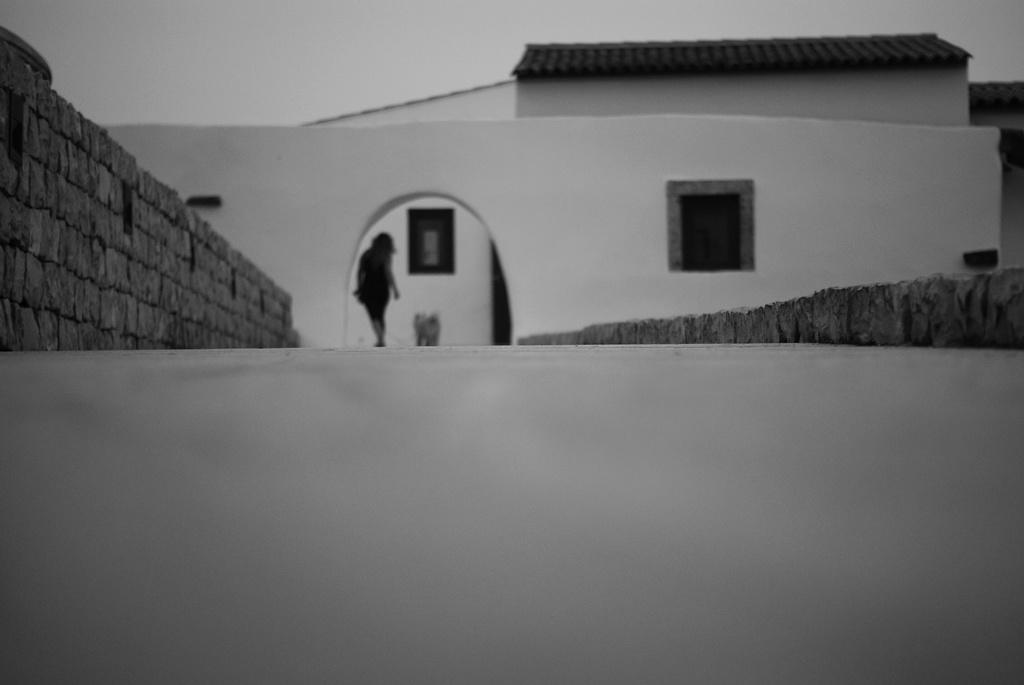What type of structure is visible in the image? There is a building in the image. What architectural feature can be seen on the building? There is a brick wall in the image. Is there any indication of the building's interior in the image? The image shows windows, which may provide a glimpse of the interior. What is the person in the image doing? A person is walking in the image. What is the color scheme of the image? The image is in black and white. Can you tell me how many drawers are visible in the image? There are no drawers present in the image. What type of show is the person in the image attending? There is no indication of a show or event in the image; it simply shows a person walking near a building. 